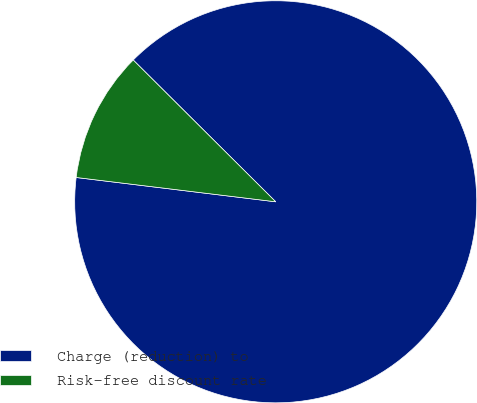Convert chart. <chart><loc_0><loc_0><loc_500><loc_500><pie_chart><fcel>Charge (reduction) to<fcel>Risk-free discount rate<nl><fcel>89.47%<fcel>10.53%<nl></chart> 